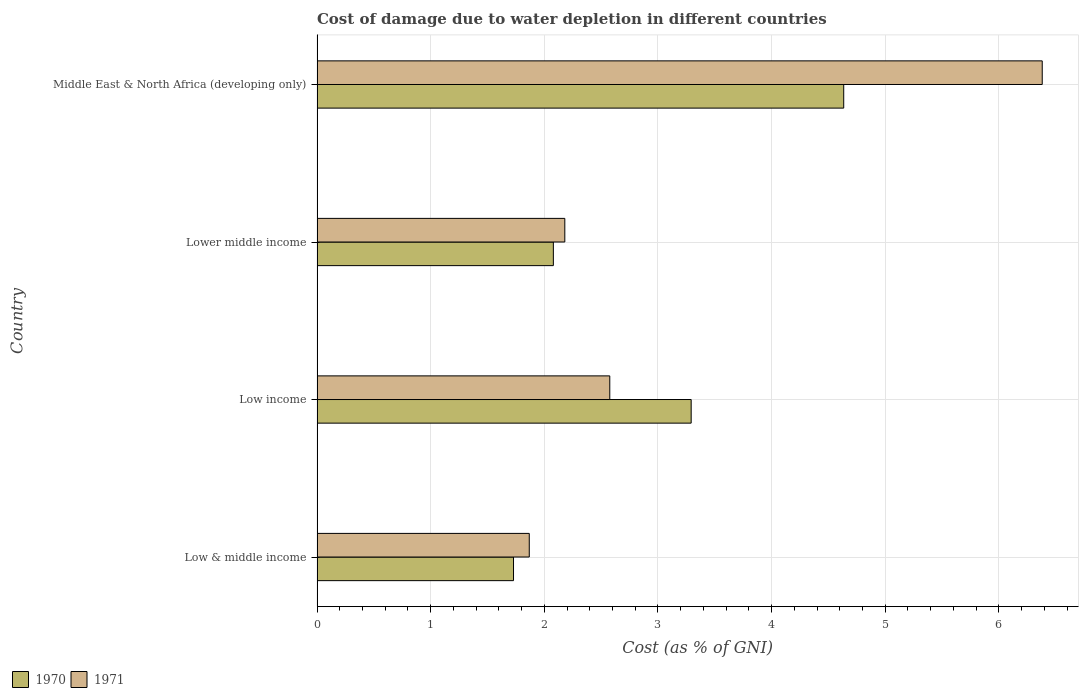How many different coloured bars are there?
Give a very brief answer. 2. Are the number of bars on each tick of the Y-axis equal?
Your answer should be very brief. Yes. How many bars are there on the 4th tick from the bottom?
Offer a terse response. 2. What is the label of the 2nd group of bars from the top?
Your answer should be very brief. Lower middle income. What is the cost of damage caused due to water depletion in 1971 in Lower middle income?
Provide a succinct answer. 2.18. Across all countries, what is the maximum cost of damage caused due to water depletion in 1970?
Your answer should be very brief. 4.63. Across all countries, what is the minimum cost of damage caused due to water depletion in 1971?
Your answer should be compact. 1.87. In which country was the cost of damage caused due to water depletion in 1970 maximum?
Your response must be concise. Middle East & North Africa (developing only). In which country was the cost of damage caused due to water depletion in 1970 minimum?
Keep it short and to the point. Low & middle income. What is the total cost of damage caused due to water depletion in 1971 in the graph?
Provide a short and direct response. 13.01. What is the difference between the cost of damage caused due to water depletion in 1971 in Low income and that in Middle East & North Africa (developing only)?
Provide a short and direct response. -3.81. What is the difference between the cost of damage caused due to water depletion in 1971 in Lower middle income and the cost of damage caused due to water depletion in 1970 in Middle East & North Africa (developing only)?
Your answer should be very brief. -2.45. What is the average cost of damage caused due to water depletion in 1971 per country?
Your response must be concise. 3.25. What is the difference between the cost of damage caused due to water depletion in 1971 and cost of damage caused due to water depletion in 1970 in Low & middle income?
Your answer should be compact. 0.14. What is the ratio of the cost of damage caused due to water depletion in 1970 in Low income to that in Lower middle income?
Offer a very short reply. 1.58. Is the cost of damage caused due to water depletion in 1970 in Low & middle income less than that in Middle East & North Africa (developing only)?
Provide a succinct answer. Yes. What is the difference between the highest and the second highest cost of damage caused due to water depletion in 1970?
Your answer should be very brief. 1.34. What is the difference between the highest and the lowest cost of damage caused due to water depletion in 1970?
Your answer should be very brief. 2.91. Is the sum of the cost of damage caused due to water depletion in 1970 in Low & middle income and Middle East & North Africa (developing only) greater than the maximum cost of damage caused due to water depletion in 1971 across all countries?
Offer a very short reply. No. What does the 1st bar from the top in Middle East & North Africa (developing only) represents?
Provide a short and direct response. 1971. What does the 1st bar from the bottom in Lower middle income represents?
Keep it short and to the point. 1970. Are all the bars in the graph horizontal?
Your answer should be compact. Yes. How many countries are there in the graph?
Give a very brief answer. 4. What is the difference between two consecutive major ticks on the X-axis?
Your response must be concise. 1. Are the values on the major ticks of X-axis written in scientific E-notation?
Offer a very short reply. No. Where does the legend appear in the graph?
Ensure brevity in your answer.  Bottom left. How many legend labels are there?
Offer a terse response. 2. How are the legend labels stacked?
Offer a terse response. Horizontal. What is the title of the graph?
Make the answer very short. Cost of damage due to water depletion in different countries. What is the label or title of the X-axis?
Your answer should be very brief. Cost (as % of GNI). What is the Cost (as % of GNI) of 1970 in Low & middle income?
Provide a short and direct response. 1.73. What is the Cost (as % of GNI) in 1971 in Low & middle income?
Your answer should be very brief. 1.87. What is the Cost (as % of GNI) of 1970 in Low income?
Provide a succinct answer. 3.29. What is the Cost (as % of GNI) in 1971 in Low income?
Ensure brevity in your answer.  2.58. What is the Cost (as % of GNI) in 1970 in Lower middle income?
Your response must be concise. 2.08. What is the Cost (as % of GNI) of 1971 in Lower middle income?
Your answer should be very brief. 2.18. What is the Cost (as % of GNI) of 1970 in Middle East & North Africa (developing only)?
Make the answer very short. 4.63. What is the Cost (as % of GNI) of 1971 in Middle East & North Africa (developing only)?
Your answer should be compact. 6.38. Across all countries, what is the maximum Cost (as % of GNI) in 1970?
Provide a succinct answer. 4.63. Across all countries, what is the maximum Cost (as % of GNI) in 1971?
Provide a succinct answer. 6.38. Across all countries, what is the minimum Cost (as % of GNI) in 1970?
Offer a very short reply. 1.73. Across all countries, what is the minimum Cost (as % of GNI) in 1971?
Make the answer very short. 1.87. What is the total Cost (as % of GNI) of 1970 in the graph?
Offer a terse response. 11.74. What is the total Cost (as % of GNI) in 1971 in the graph?
Give a very brief answer. 13.01. What is the difference between the Cost (as % of GNI) in 1970 in Low & middle income and that in Low income?
Provide a short and direct response. -1.56. What is the difference between the Cost (as % of GNI) of 1971 in Low & middle income and that in Low income?
Your response must be concise. -0.71. What is the difference between the Cost (as % of GNI) in 1970 in Low & middle income and that in Lower middle income?
Keep it short and to the point. -0.35. What is the difference between the Cost (as % of GNI) of 1971 in Low & middle income and that in Lower middle income?
Offer a very short reply. -0.31. What is the difference between the Cost (as % of GNI) in 1970 in Low & middle income and that in Middle East & North Africa (developing only)?
Your response must be concise. -2.91. What is the difference between the Cost (as % of GNI) of 1971 in Low & middle income and that in Middle East & North Africa (developing only)?
Offer a very short reply. -4.51. What is the difference between the Cost (as % of GNI) of 1970 in Low income and that in Lower middle income?
Your answer should be very brief. 1.21. What is the difference between the Cost (as % of GNI) in 1971 in Low income and that in Lower middle income?
Make the answer very short. 0.4. What is the difference between the Cost (as % of GNI) in 1970 in Low income and that in Middle East & North Africa (developing only)?
Provide a short and direct response. -1.34. What is the difference between the Cost (as % of GNI) of 1971 in Low income and that in Middle East & North Africa (developing only)?
Your answer should be very brief. -3.81. What is the difference between the Cost (as % of GNI) in 1970 in Lower middle income and that in Middle East & North Africa (developing only)?
Your answer should be compact. -2.56. What is the difference between the Cost (as % of GNI) in 1971 in Lower middle income and that in Middle East & North Africa (developing only)?
Provide a short and direct response. -4.2. What is the difference between the Cost (as % of GNI) of 1970 in Low & middle income and the Cost (as % of GNI) of 1971 in Low income?
Offer a terse response. -0.85. What is the difference between the Cost (as % of GNI) of 1970 in Low & middle income and the Cost (as % of GNI) of 1971 in Lower middle income?
Give a very brief answer. -0.45. What is the difference between the Cost (as % of GNI) in 1970 in Low & middle income and the Cost (as % of GNI) in 1971 in Middle East & North Africa (developing only)?
Provide a succinct answer. -4.65. What is the difference between the Cost (as % of GNI) in 1970 in Low income and the Cost (as % of GNI) in 1971 in Lower middle income?
Provide a succinct answer. 1.11. What is the difference between the Cost (as % of GNI) of 1970 in Low income and the Cost (as % of GNI) of 1971 in Middle East & North Africa (developing only)?
Keep it short and to the point. -3.09. What is the difference between the Cost (as % of GNI) of 1970 in Lower middle income and the Cost (as % of GNI) of 1971 in Middle East & North Africa (developing only)?
Your response must be concise. -4.3. What is the average Cost (as % of GNI) of 1970 per country?
Keep it short and to the point. 2.93. What is the average Cost (as % of GNI) in 1971 per country?
Provide a short and direct response. 3.25. What is the difference between the Cost (as % of GNI) of 1970 and Cost (as % of GNI) of 1971 in Low & middle income?
Provide a short and direct response. -0.14. What is the difference between the Cost (as % of GNI) of 1970 and Cost (as % of GNI) of 1971 in Low income?
Offer a terse response. 0.72. What is the difference between the Cost (as % of GNI) of 1970 and Cost (as % of GNI) of 1971 in Lower middle income?
Provide a succinct answer. -0.1. What is the difference between the Cost (as % of GNI) in 1970 and Cost (as % of GNI) in 1971 in Middle East & North Africa (developing only)?
Offer a terse response. -1.75. What is the ratio of the Cost (as % of GNI) in 1970 in Low & middle income to that in Low income?
Ensure brevity in your answer.  0.53. What is the ratio of the Cost (as % of GNI) in 1971 in Low & middle income to that in Low income?
Give a very brief answer. 0.72. What is the ratio of the Cost (as % of GNI) in 1970 in Low & middle income to that in Lower middle income?
Provide a short and direct response. 0.83. What is the ratio of the Cost (as % of GNI) in 1971 in Low & middle income to that in Lower middle income?
Provide a succinct answer. 0.86. What is the ratio of the Cost (as % of GNI) of 1970 in Low & middle income to that in Middle East & North Africa (developing only)?
Your answer should be very brief. 0.37. What is the ratio of the Cost (as % of GNI) of 1971 in Low & middle income to that in Middle East & North Africa (developing only)?
Your answer should be compact. 0.29. What is the ratio of the Cost (as % of GNI) in 1970 in Low income to that in Lower middle income?
Ensure brevity in your answer.  1.58. What is the ratio of the Cost (as % of GNI) of 1971 in Low income to that in Lower middle income?
Provide a succinct answer. 1.18. What is the ratio of the Cost (as % of GNI) of 1970 in Low income to that in Middle East & North Africa (developing only)?
Provide a succinct answer. 0.71. What is the ratio of the Cost (as % of GNI) of 1971 in Low income to that in Middle East & North Africa (developing only)?
Give a very brief answer. 0.4. What is the ratio of the Cost (as % of GNI) in 1970 in Lower middle income to that in Middle East & North Africa (developing only)?
Offer a terse response. 0.45. What is the ratio of the Cost (as % of GNI) of 1971 in Lower middle income to that in Middle East & North Africa (developing only)?
Ensure brevity in your answer.  0.34. What is the difference between the highest and the second highest Cost (as % of GNI) of 1970?
Make the answer very short. 1.34. What is the difference between the highest and the second highest Cost (as % of GNI) of 1971?
Your answer should be very brief. 3.81. What is the difference between the highest and the lowest Cost (as % of GNI) of 1970?
Offer a terse response. 2.91. What is the difference between the highest and the lowest Cost (as % of GNI) of 1971?
Your answer should be compact. 4.51. 